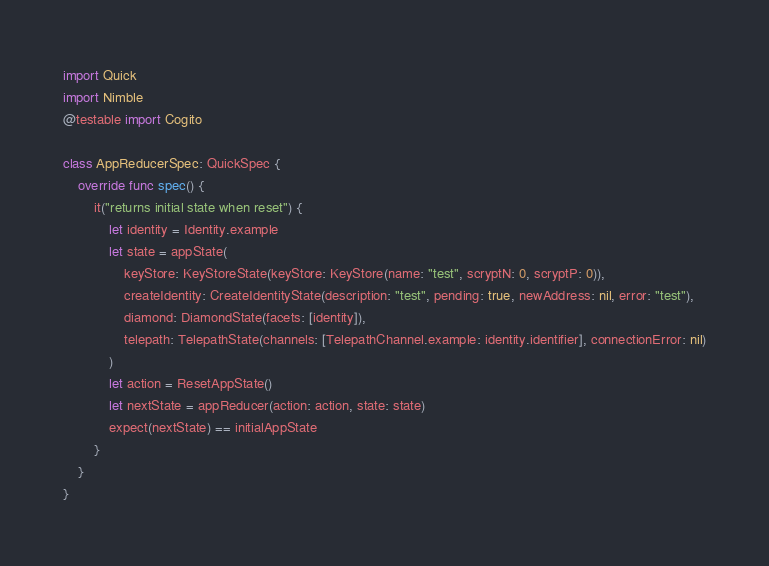<code> <loc_0><loc_0><loc_500><loc_500><_Swift_>import Quick
import Nimble
@testable import Cogito

class AppReducerSpec: QuickSpec {
    override func spec() {
        it("returns initial state when reset") {
            let identity = Identity.example
            let state = appState(
                keyStore: KeyStoreState(keyStore: KeyStore(name: "test", scryptN: 0, scryptP: 0)),
                createIdentity: CreateIdentityState(description: "test", pending: true, newAddress: nil, error: "test"),
                diamond: DiamondState(facets: [identity]),
                telepath: TelepathState(channels: [TelepathChannel.example: identity.identifier], connectionError: nil)
            )
            let action = ResetAppState()
            let nextState = appReducer(action: action, state: state)
            expect(nextState) == initialAppState
        }
    }
}
</code> 